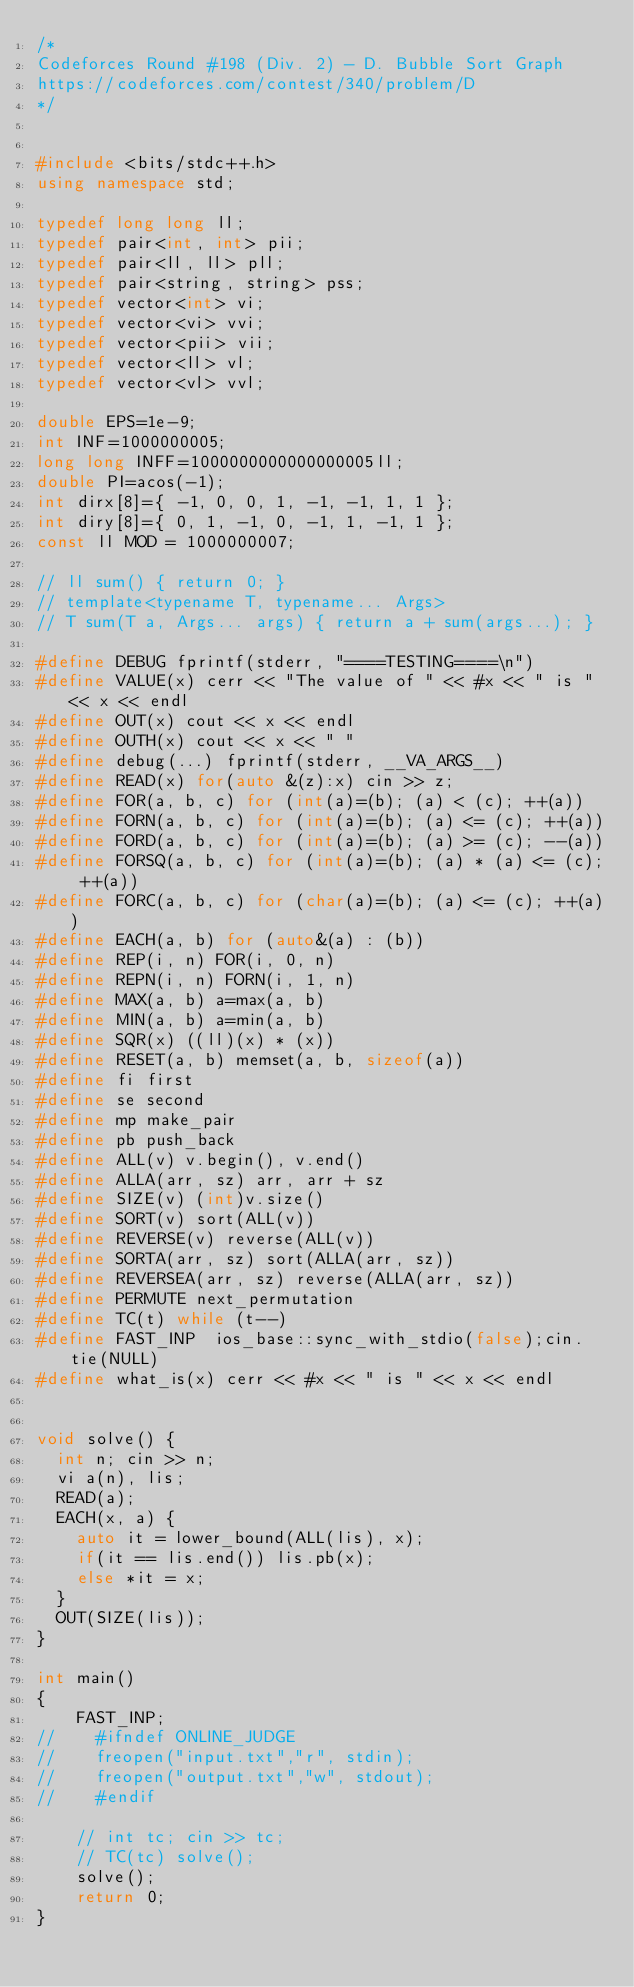Convert code to text. <code><loc_0><loc_0><loc_500><loc_500><_C++_>/*
Codeforces Round #198 (Div. 2) - D. Bubble Sort Graph
https://codeforces.com/contest/340/problem/D
*/


#include <bits/stdc++.h>
using namespace std;

typedef long long ll;
typedef pair<int, int> pii;
typedef pair<ll, ll> pll;
typedef pair<string, string> pss;
typedef vector<int> vi;
typedef vector<vi> vvi;
typedef vector<pii> vii;
typedef vector<ll> vl;
typedef vector<vl> vvl;

double EPS=1e-9;
int INF=1000000005;
long long INFF=1000000000000000005ll;
double PI=acos(-1);
int dirx[8]={ -1, 0, 0, 1, -1, -1, 1, 1 };
int diry[8]={ 0, 1, -1, 0, -1, 1, -1, 1 };
const ll MOD = 1000000007;

// ll sum() { return 0; }
// template<typename T, typename... Args>
// T sum(T a, Args... args) { return a + sum(args...); }

#define DEBUG fprintf(stderr, "====TESTING====\n")
#define VALUE(x) cerr << "The value of " << #x << " is " << x << endl
#define OUT(x) cout << x << endl
#define OUTH(x) cout << x << " "
#define debug(...) fprintf(stderr, __VA_ARGS__)
#define READ(x) for(auto &(z):x) cin >> z;
#define FOR(a, b, c) for (int(a)=(b); (a) < (c); ++(a))
#define FORN(a, b, c) for (int(a)=(b); (a) <= (c); ++(a))
#define FORD(a, b, c) for (int(a)=(b); (a) >= (c); --(a))
#define FORSQ(a, b, c) for (int(a)=(b); (a) * (a) <= (c); ++(a))
#define FORC(a, b, c) for (char(a)=(b); (a) <= (c); ++(a))
#define EACH(a, b) for (auto&(a) : (b))
#define REP(i, n) FOR(i, 0, n)
#define REPN(i, n) FORN(i, 1, n)
#define MAX(a, b) a=max(a, b)
#define MIN(a, b) a=min(a, b)
#define SQR(x) ((ll)(x) * (x))
#define RESET(a, b) memset(a, b, sizeof(a))
#define fi first
#define se second
#define mp make_pair
#define pb push_back
#define ALL(v) v.begin(), v.end()
#define ALLA(arr, sz) arr, arr + sz
#define SIZE(v) (int)v.size()
#define SORT(v) sort(ALL(v))
#define REVERSE(v) reverse(ALL(v))
#define SORTA(arr, sz) sort(ALLA(arr, sz))
#define REVERSEA(arr, sz) reverse(ALLA(arr, sz))
#define PERMUTE next_permutation
#define TC(t) while (t--)
#define FAST_INP  ios_base::sync_with_stdio(false);cin.tie(NULL)
#define what_is(x) cerr << #x << " is " << x << endl


void solve() {
	int n; cin >> n;
	vi a(n), lis;
	READ(a);
	EACH(x, a) {
		auto it = lower_bound(ALL(lis), x);
		if(it == lis.end()) lis.pb(x);
		else *it = x;
	}
	OUT(SIZE(lis));
}

int main()
{
    FAST_INP;
//    #ifndef ONLINE_JUDGE
//    freopen("input.txt","r", stdin);
//    freopen("output.txt","w", stdout);
//    #endif

    // int tc; cin >> tc;
    // TC(tc) solve();
    solve();
    return 0;
}

</code> 